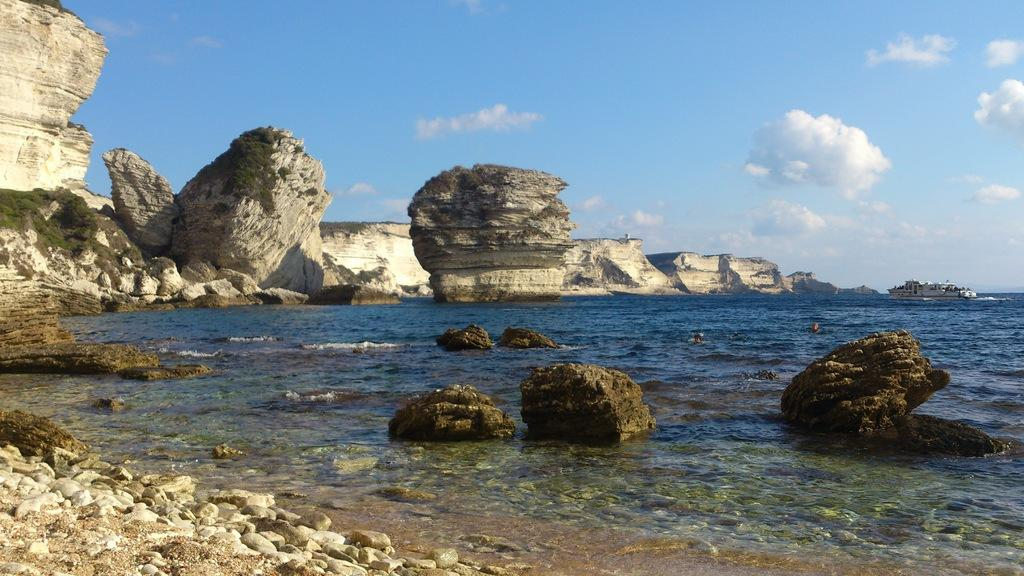What type of natural elements can be seen in the image? There are rocks and water in the image. What is the ferry's mode of transportation in the image? The ferry is on the water in the image. What type of business is being conducted on the ferry in the image? There is no indication of any business being conducted on the ferry in the image. What is the size of the rocks in the image? The size of the rocks cannot be determined from the image alone, as there is no scale provided. 